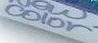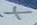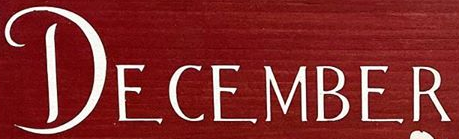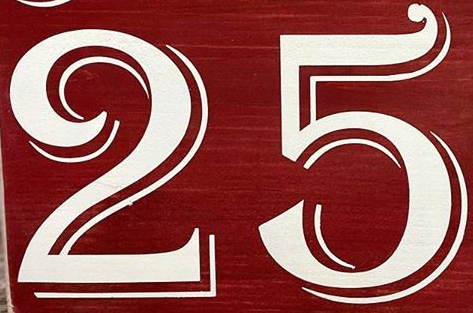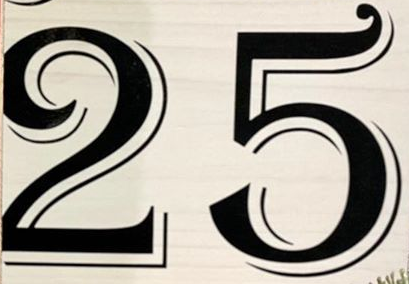Transcribe the words shown in these images in order, separated by a semicolon. color; X; DECEMBER; 25; 25 